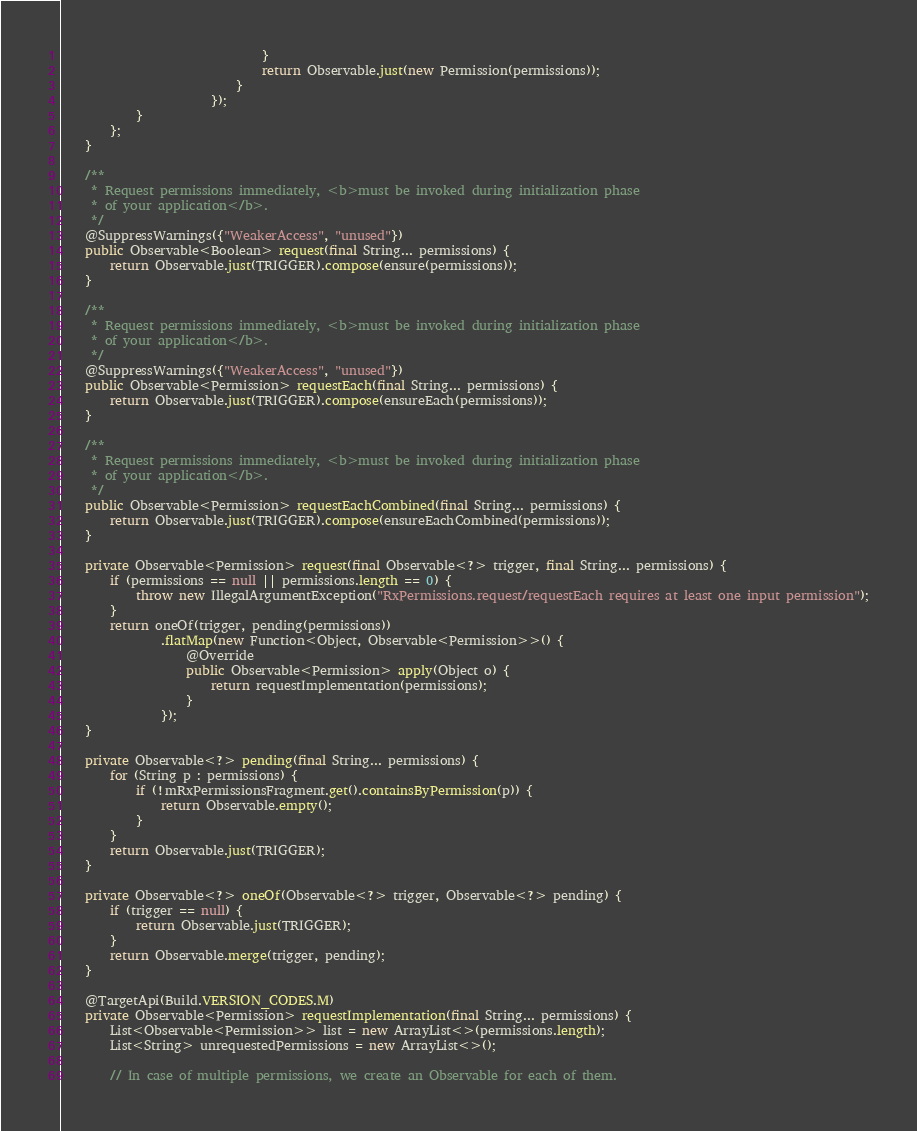<code> <loc_0><loc_0><loc_500><loc_500><_Java_>                                }
                                return Observable.just(new Permission(permissions));
                            }
                        });
            }
        };
    }

    /**
     * Request permissions immediately, <b>must be invoked during initialization phase
     * of your application</b>.
     */
    @SuppressWarnings({"WeakerAccess", "unused"})
    public Observable<Boolean> request(final String... permissions) {
        return Observable.just(TRIGGER).compose(ensure(permissions));
    }

    /**
     * Request permissions immediately, <b>must be invoked during initialization phase
     * of your application</b>.
     */
    @SuppressWarnings({"WeakerAccess", "unused"})
    public Observable<Permission> requestEach(final String... permissions) {
        return Observable.just(TRIGGER).compose(ensureEach(permissions));
    }

    /**
     * Request permissions immediately, <b>must be invoked during initialization phase
     * of your application</b>.
     */
    public Observable<Permission> requestEachCombined(final String... permissions) {
        return Observable.just(TRIGGER).compose(ensureEachCombined(permissions));
    }

    private Observable<Permission> request(final Observable<?> trigger, final String... permissions) {
        if (permissions == null || permissions.length == 0) {
            throw new IllegalArgumentException("RxPermissions.request/requestEach requires at least one input permission");
        }
        return oneOf(trigger, pending(permissions))
                .flatMap(new Function<Object, Observable<Permission>>() {
                    @Override
                    public Observable<Permission> apply(Object o) {
                        return requestImplementation(permissions);
                    }
                });
    }

    private Observable<?> pending(final String... permissions) {
        for (String p : permissions) {
            if (!mRxPermissionsFragment.get().containsByPermission(p)) {
                return Observable.empty();
            }
        }
        return Observable.just(TRIGGER);
    }

    private Observable<?> oneOf(Observable<?> trigger, Observable<?> pending) {
        if (trigger == null) {
            return Observable.just(TRIGGER);
        }
        return Observable.merge(trigger, pending);
    }

    @TargetApi(Build.VERSION_CODES.M)
    private Observable<Permission> requestImplementation(final String... permissions) {
        List<Observable<Permission>> list = new ArrayList<>(permissions.length);
        List<String> unrequestedPermissions = new ArrayList<>();

        // In case of multiple permissions, we create an Observable for each of them.</code> 